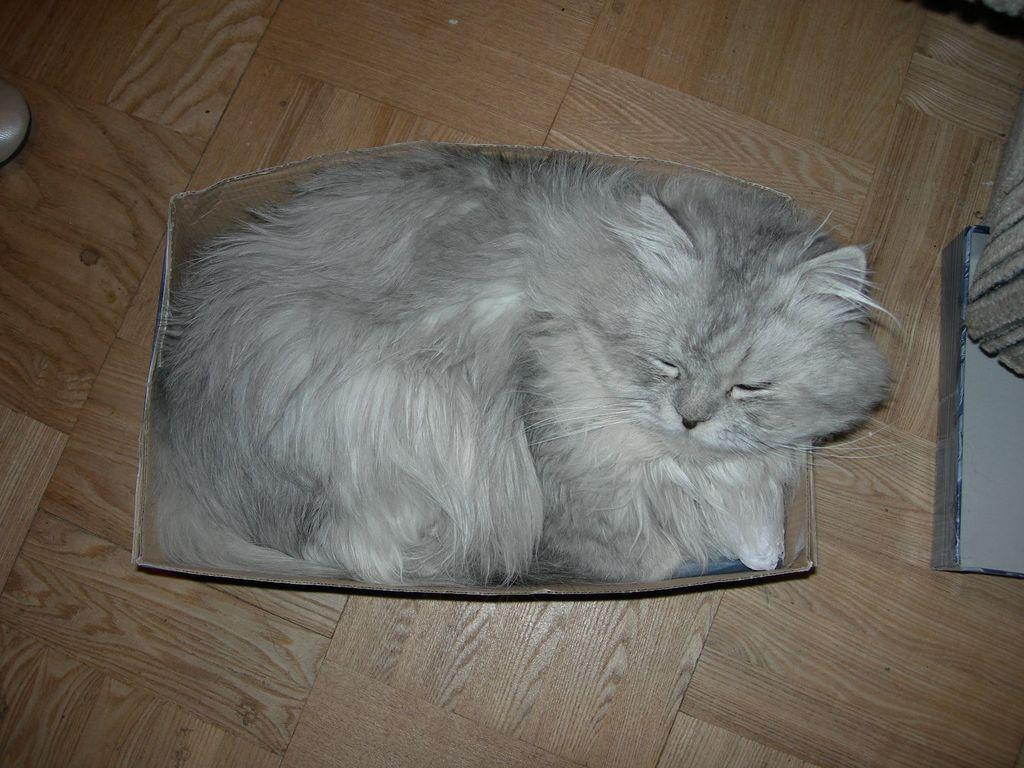What animal can be seen in the image? There is a cat in the image. What is the cat doing in the image? The cat is laying in a box. Where is the box with the cat located? The box is placed on the floor. What else can be seen on the right side of the image? There are other objects on the right side of the image. What type of insurance policy does the cat have in the image? There is no mention of insurance in the image, and the cat does not have any visible insurance policy. 